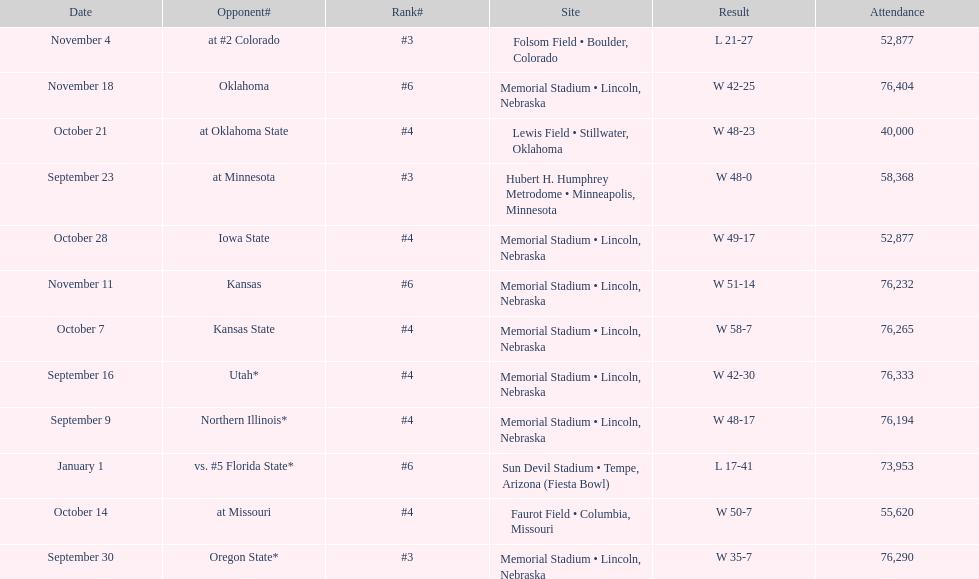When is the first game? September 9. 